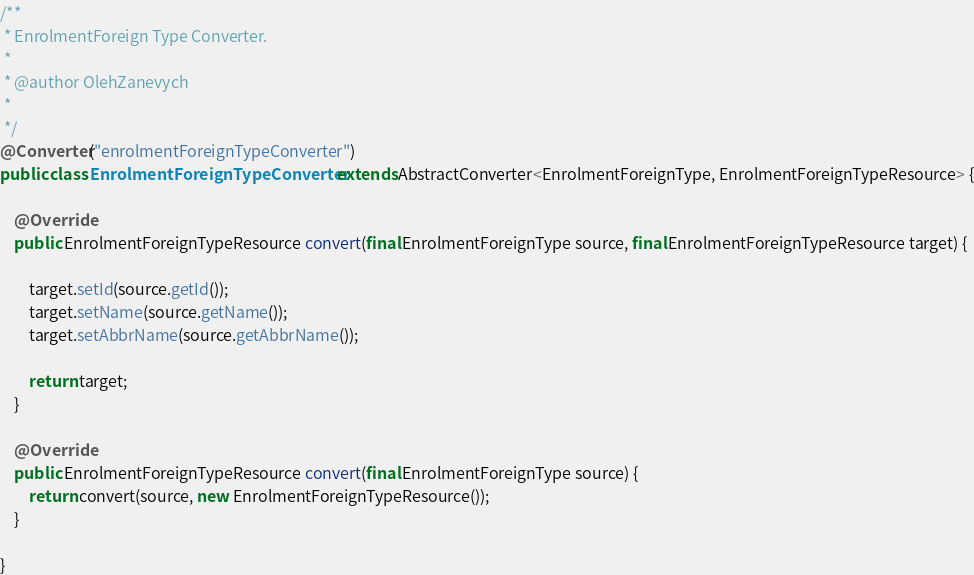Convert code to text. <code><loc_0><loc_0><loc_500><loc_500><_Java_>
/**
 * EnrolmentForeign Type Converter.
 * 
 * @author OlehZanevych
 * 
 */
@Converter("enrolmentForeignTypeConverter")
public class EnrolmentForeignTypeConverter extends AbstractConverter<EnrolmentForeignType, EnrolmentForeignTypeResource> {

	@Override
	public EnrolmentForeignTypeResource convert(final EnrolmentForeignType source, final EnrolmentForeignTypeResource target) {

		target.setId(source.getId());
		target.setName(source.getName());
		target.setAbbrName(source.getAbbrName());

		return target;
	}

	@Override
	public EnrolmentForeignTypeResource convert(final EnrolmentForeignType source) {
		return convert(source, new EnrolmentForeignTypeResource());
	}

}
</code> 